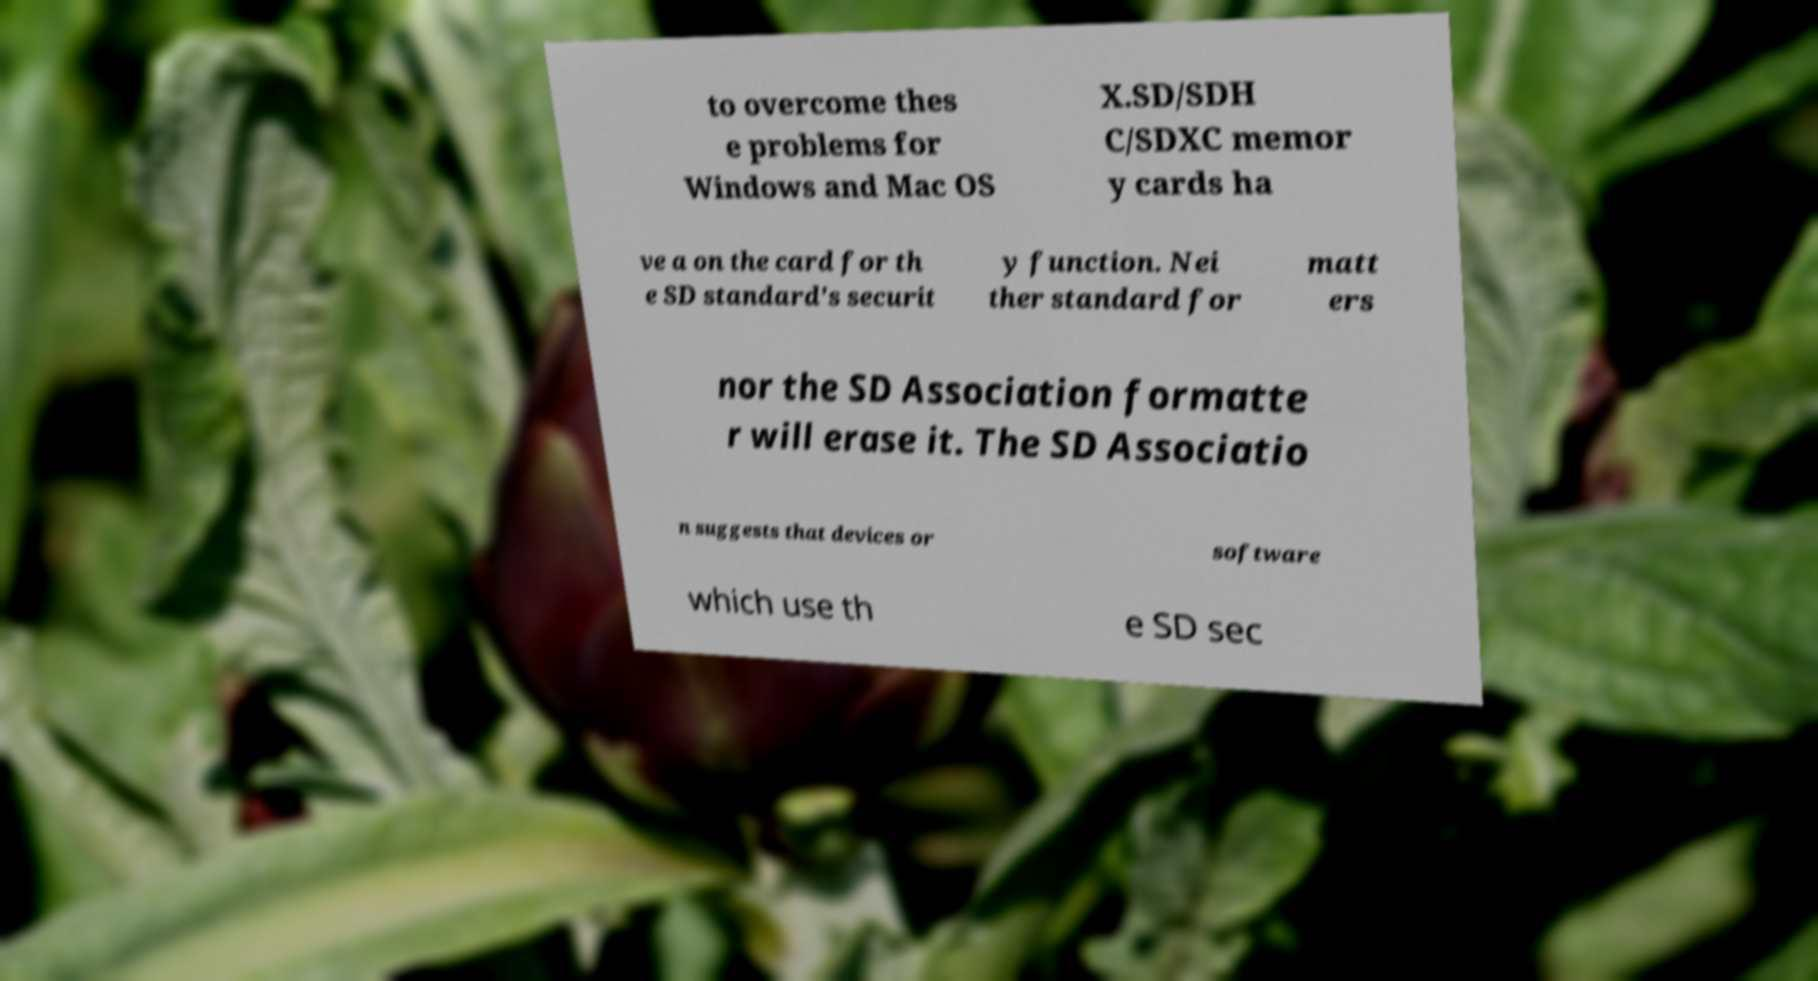Please identify and transcribe the text found in this image. to overcome thes e problems for Windows and Mac OS X.SD/SDH C/SDXC memor y cards ha ve a on the card for th e SD standard's securit y function. Nei ther standard for matt ers nor the SD Association formatte r will erase it. The SD Associatio n suggests that devices or software which use th e SD sec 